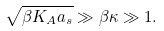<formula> <loc_0><loc_0><loc_500><loc_500>\sqrt { \beta K _ { A } a _ { s } } \gg \beta \kappa \gg 1 .</formula> 